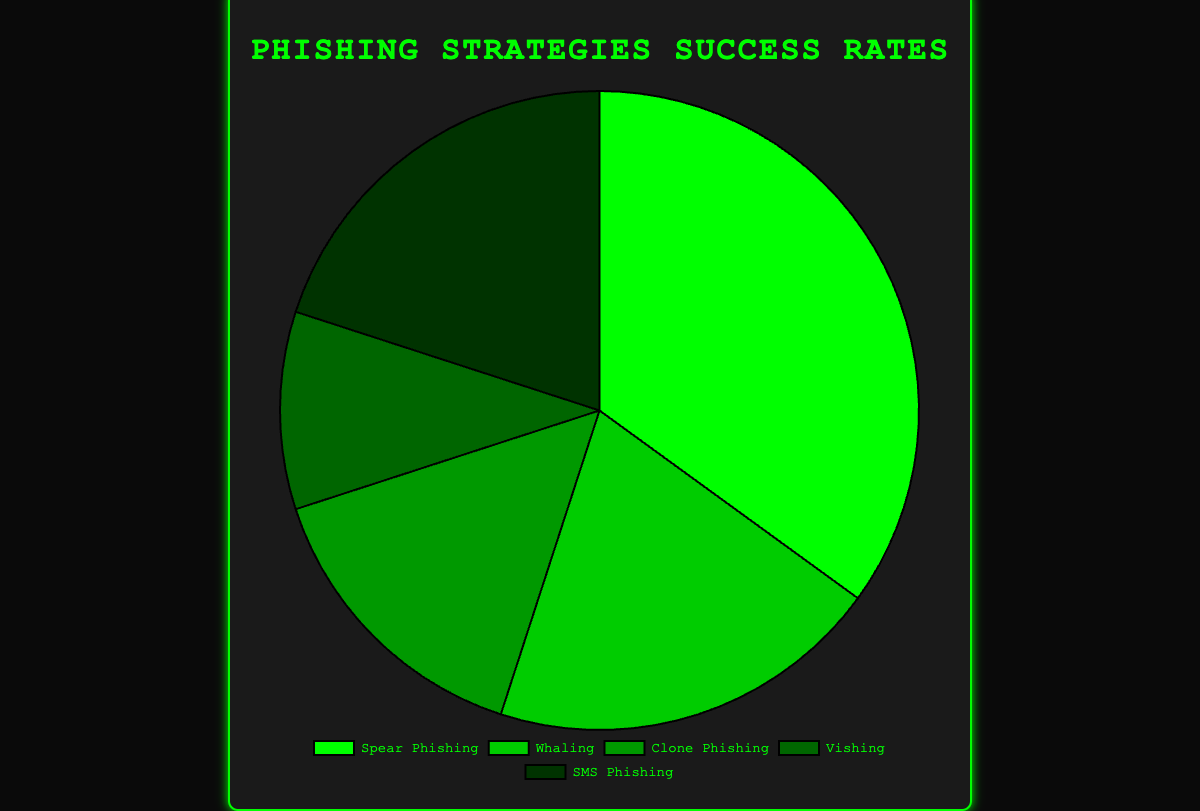How many more successful attempts did Spear Phishing have compared to Vishing? Spear Phishing has a success rate of 35%, while Vishing has a success rate of 10%. To find the difference, subtract Vishing's rate from Spear Phishing's rate: 35% - 10% = 25%.
Answer: 25% Which two strategies have equal success rates? Referring to the figure, both Whaling and SMS Phishing have success rates of 20%.
Answer: Whaling and SMS Phishing Which strategy has the highest success rate? By looking at the success rates, Spear Phishing has the highest success rate of 35%.
Answer: Spear Phishing What is the combined success rate of Clone Phishing and Vishing? Clone Phishing has a success rate of 15%, and Vishing has a success rate of 10%. Adding these together gives 15% + 10% = 25%.
Answer: 25% Which strategy has the second-lowest success rate? Vishing has the lowest success rate at 10%, and the next lowest is Clone Phishing at 15%.
Answer: Clone Phishing How much higher is the success rate of SMS Phishing compared to Vishing? SMS Phishing has a success rate of 20%, and Vishing's success rate is 10%. Subtracting Vishing's rate from SMS Phishing's rate gives 20% - 10% = 10%.
Answer: 10% What's the total success rate of all strategies combined? Adding up all the success rates: 35 (Spear Phishing) + 20 (Whaling) + 15 (Clone Phishing) + 10 (Vishing) + 20 (SMS Phishing) = 100%.
Answer: 100% What is the difference in success rates between the most successful and least successful strategies? The most successful strategy is Spear Phishing (35%) and the least successful is Vishing (10%). The difference is 35% - 10% = 25%.
Answer: 25% If Whaling's success rate increased to match Spear Phishing's, what would it be? Currently, Spear Phishing has a success rate of 35%. If Whaling increased to match it, Whaling's success rate would also be 35%.
Answer: 35% Is the combined success rate of Whaling and SMS Phishing greater than Spear Phishing? Whaling (20%) + SMS Phishing (20%) = 40%, which is greater than Spear Phishing's 35%.
Answer: Yes 